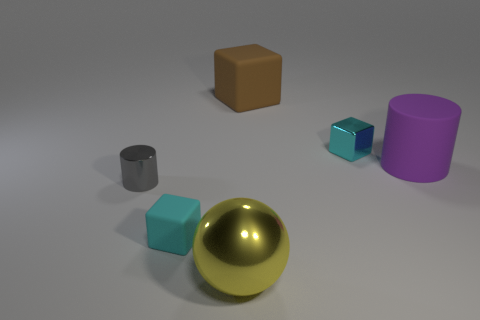Add 1 cyan metallic blocks. How many objects exist? 7 Subtract all balls. How many objects are left? 5 Subtract 0 cyan spheres. How many objects are left? 6 Subtract all cylinders. Subtract all gray shiny cylinders. How many objects are left? 3 Add 1 rubber cylinders. How many rubber cylinders are left? 2 Add 2 large yellow metal spheres. How many large yellow metal spheres exist? 3 